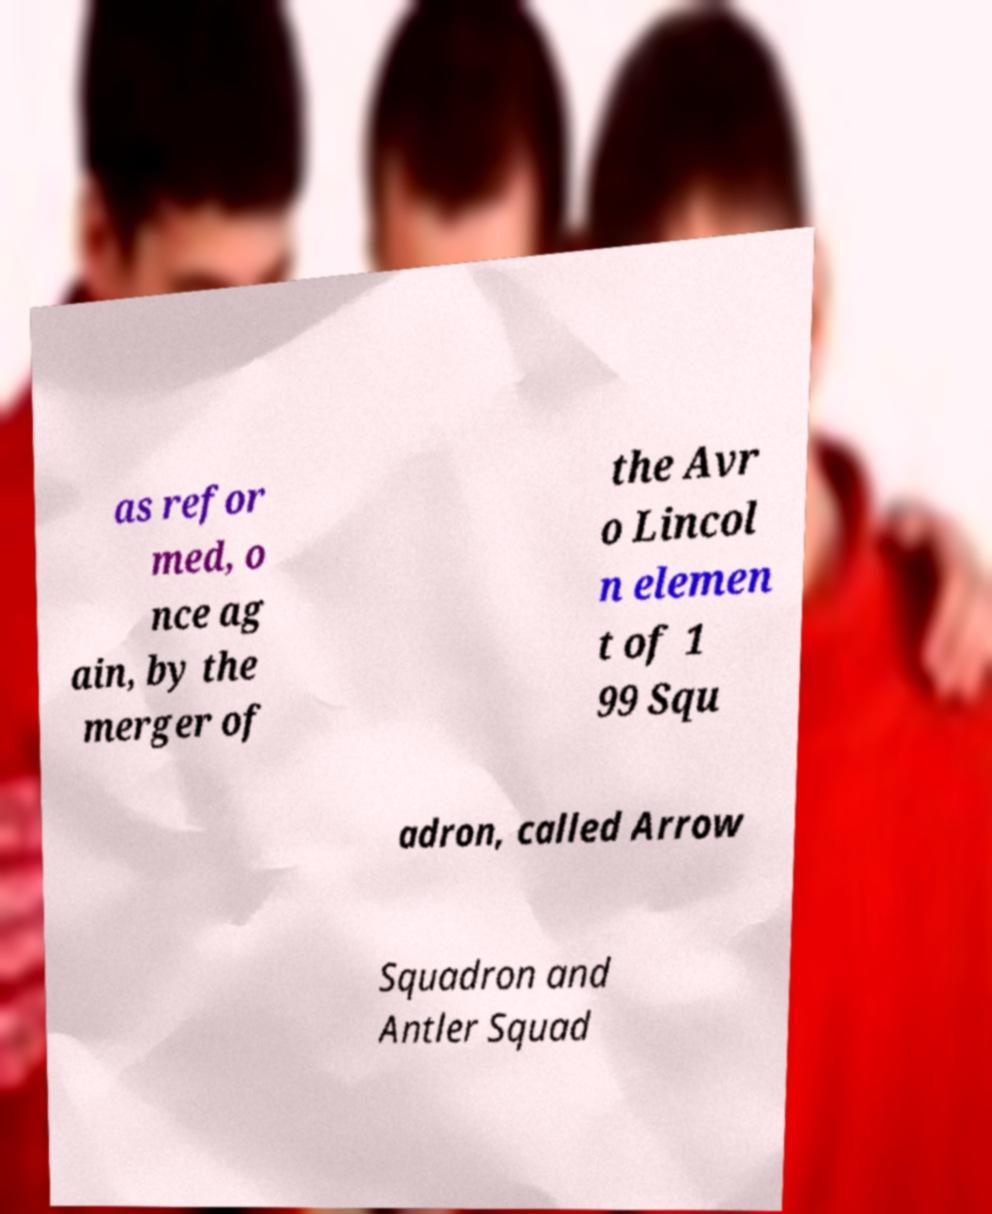Can you read and provide the text displayed in the image?This photo seems to have some interesting text. Can you extract and type it out for me? as refor med, o nce ag ain, by the merger of the Avr o Lincol n elemen t of 1 99 Squ adron, called Arrow Squadron and Antler Squad 